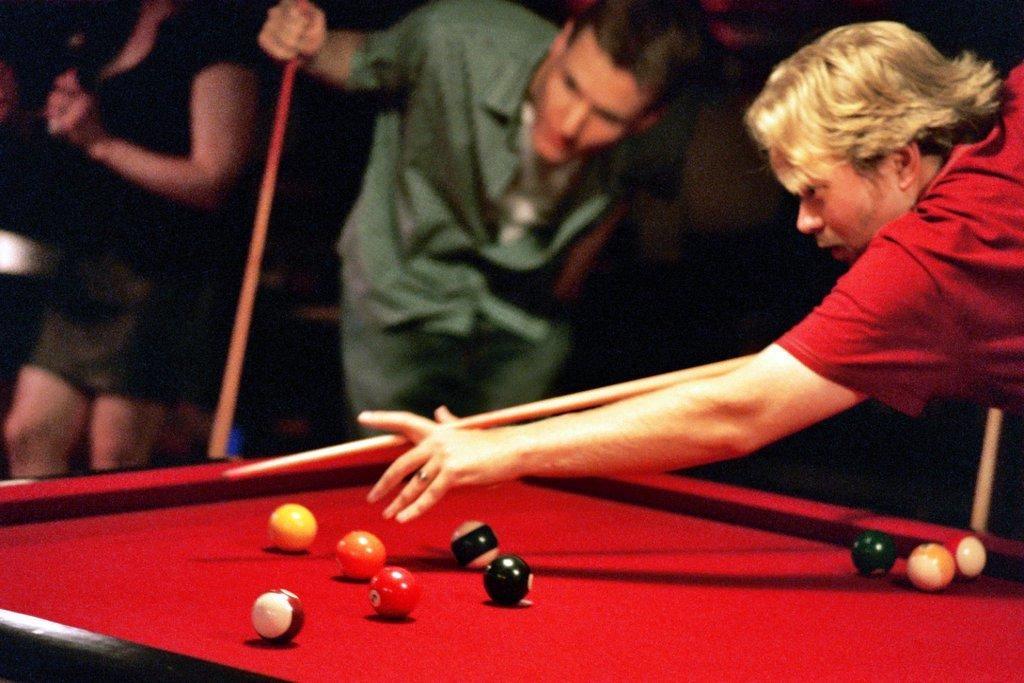Describe this image in one or two sentences. In this image there is a man standing and playing a snooker game in a snookers board , and in the back ground there are group of people standing. 